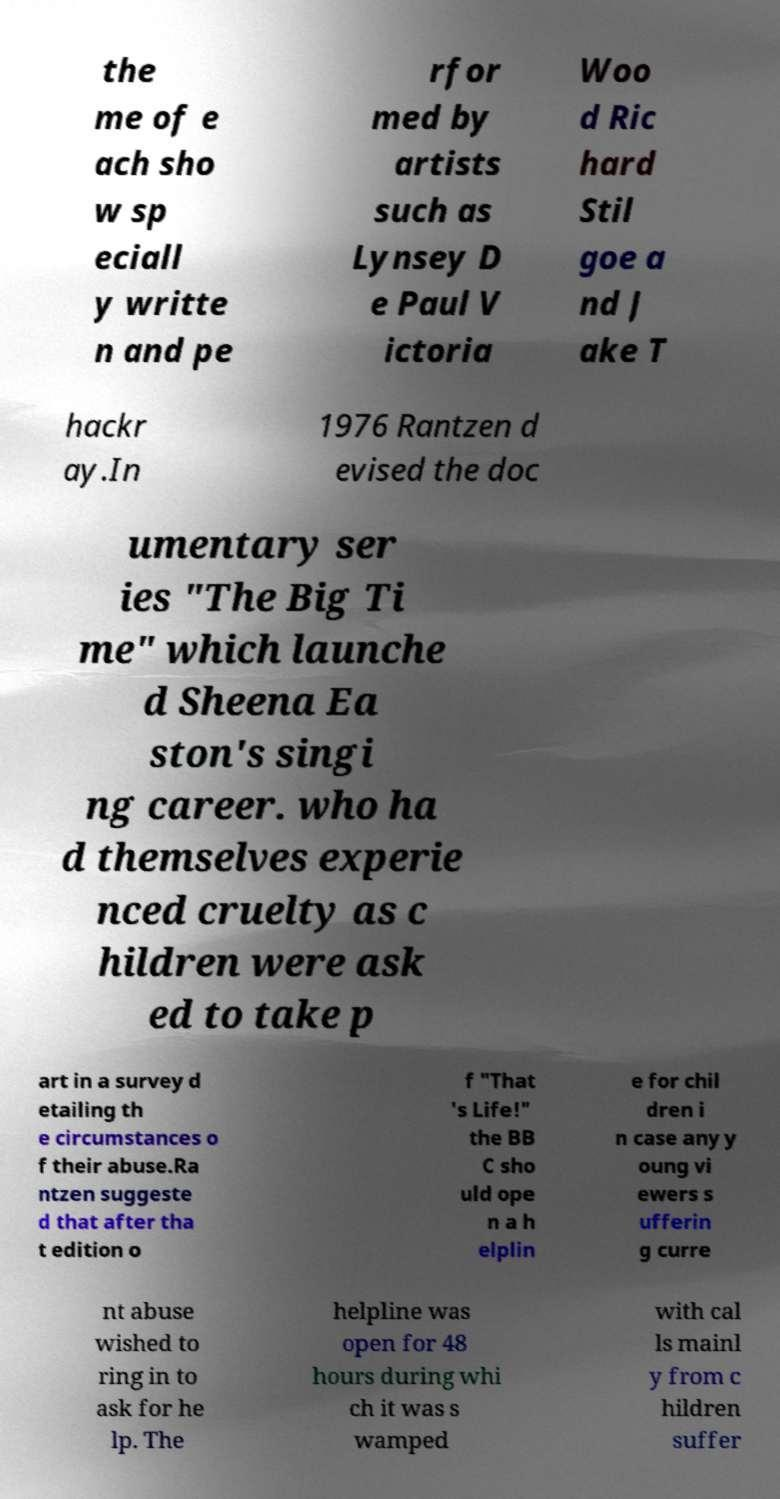There's text embedded in this image that I need extracted. Can you transcribe it verbatim? the me of e ach sho w sp eciall y writte n and pe rfor med by artists such as Lynsey D e Paul V ictoria Woo d Ric hard Stil goe a nd J ake T hackr ay.In 1976 Rantzen d evised the doc umentary ser ies "The Big Ti me" which launche d Sheena Ea ston's singi ng career. who ha d themselves experie nced cruelty as c hildren were ask ed to take p art in a survey d etailing th e circumstances o f their abuse.Ra ntzen suggeste d that after tha t edition o f "That 's Life!" the BB C sho uld ope n a h elplin e for chil dren i n case any y oung vi ewers s ufferin g curre nt abuse wished to ring in to ask for he lp. The helpline was open for 48 hours during whi ch it was s wamped with cal ls mainl y from c hildren suffer 